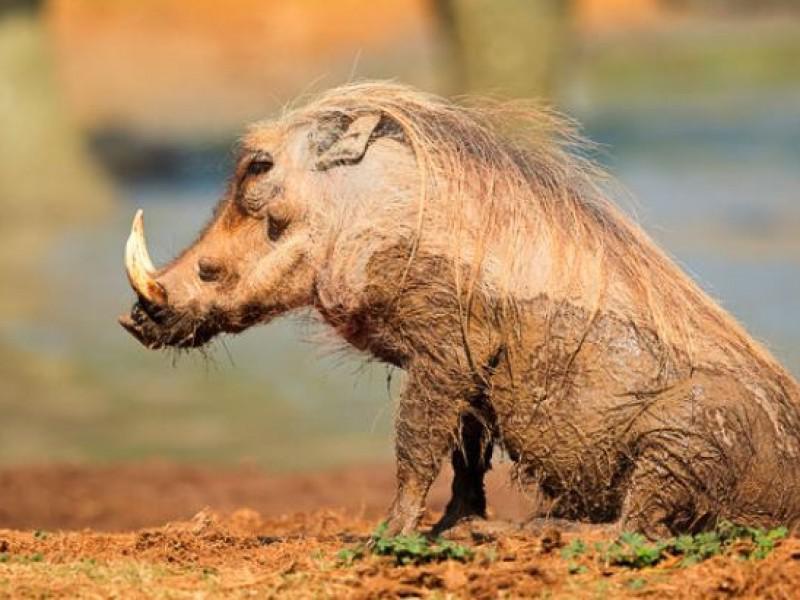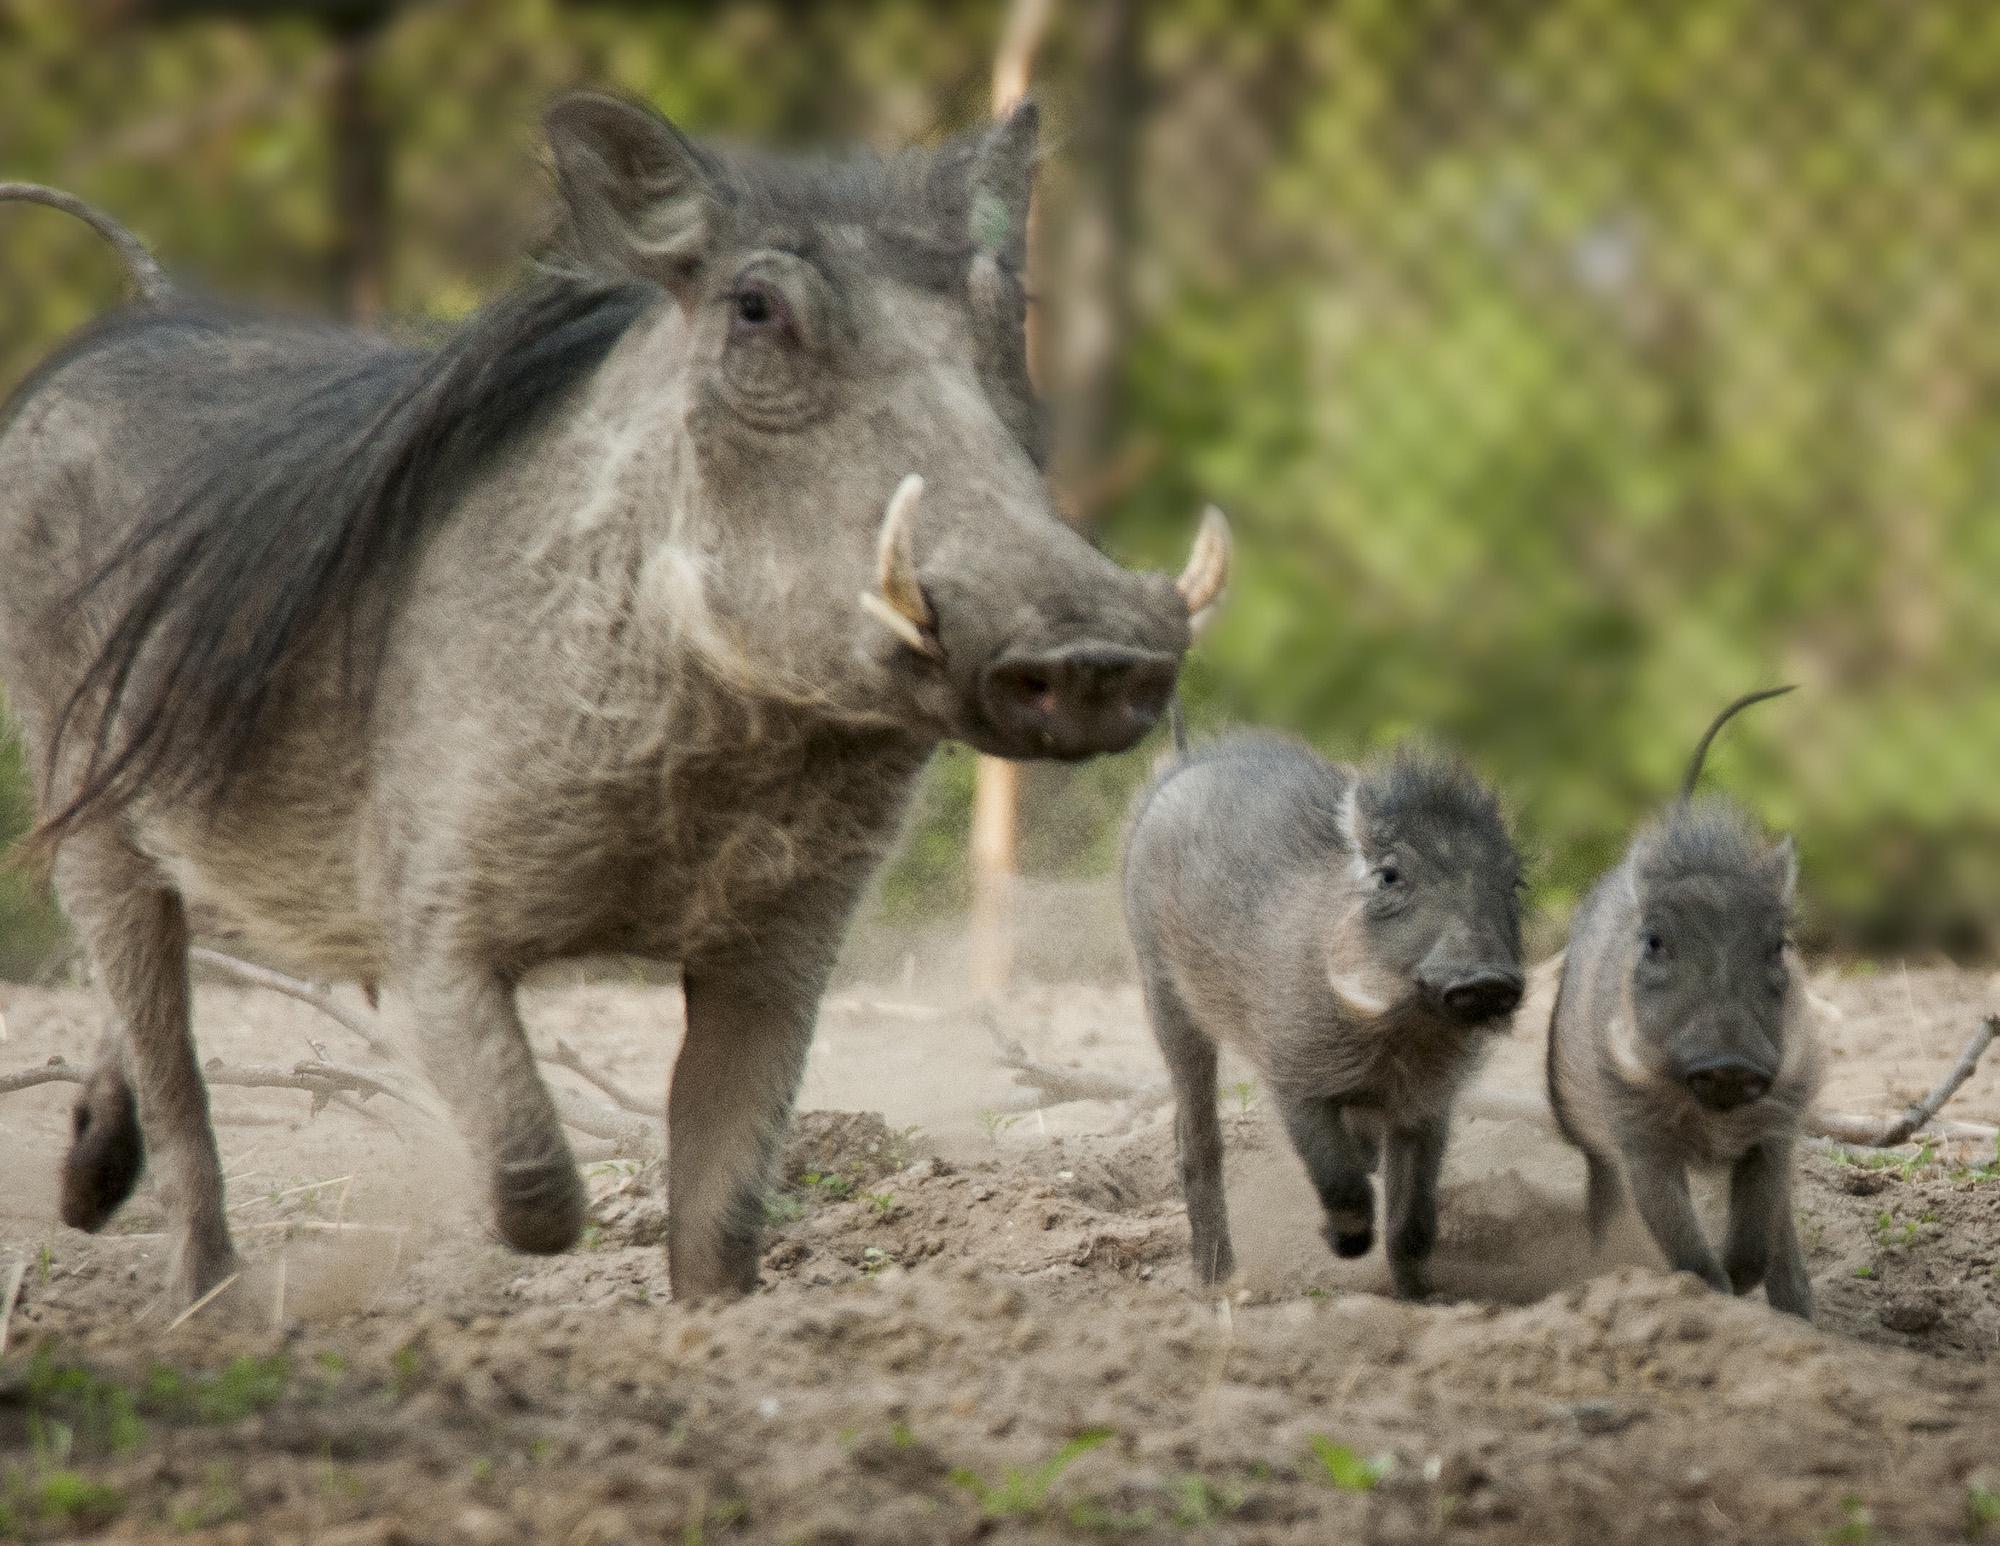The first image is the image on the left, the second image is the image on the right. For the images displayed, is the sentence "An image shows one adult warthog near two small young warthogs." factually correct? Answer yes or no. Yes. 